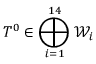<formula> <loc_0><loc_0><loc_500><loc_500>T ^ { 0 } \in \bigoplus _ { i = 1 } ^ { 1 4 } { \mathcal { W } } _ { i }</formula> 